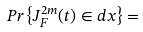Convert formula to latex. <formula><loc_0><loc_0><loc_500><loc_500>P r \left \{ J ^ { 2 m } _ { F } ( t ) \in d x \right \} =</formula> 